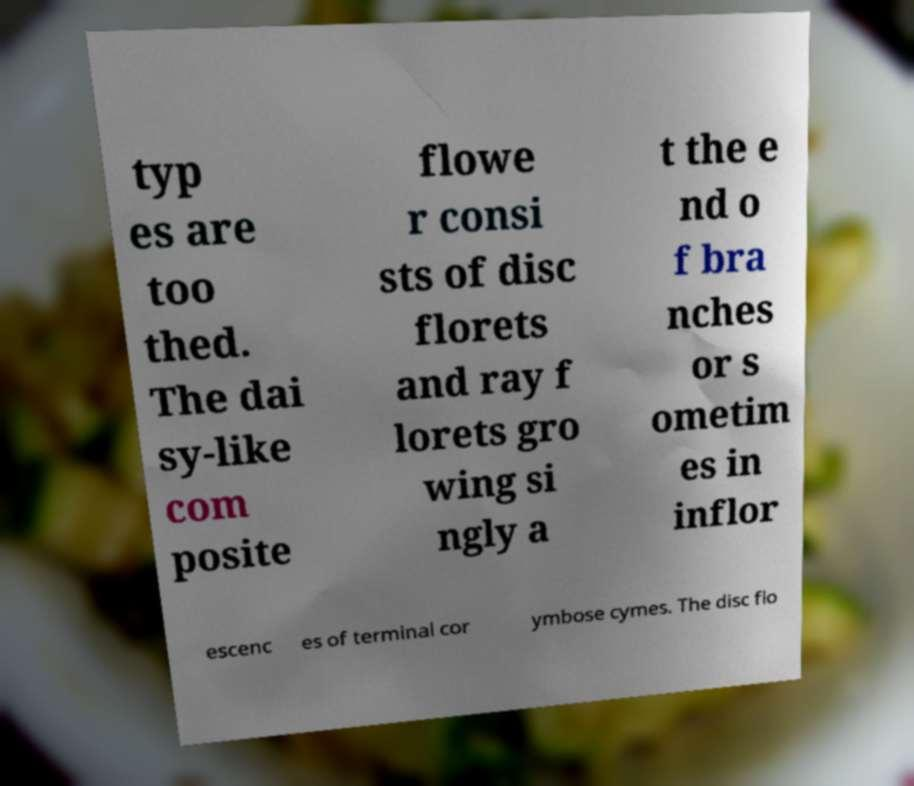Can you accurately transcribe the text from the provided image for me? typ es are too thed. The dai sy-like com posite flowe r consi sts of disc florets and ray f lorets gro wing si ngly a t the e nd o f bra nches or s ometim es in inflor escenc es of terminal cor ymbose cymes. The disc flo 